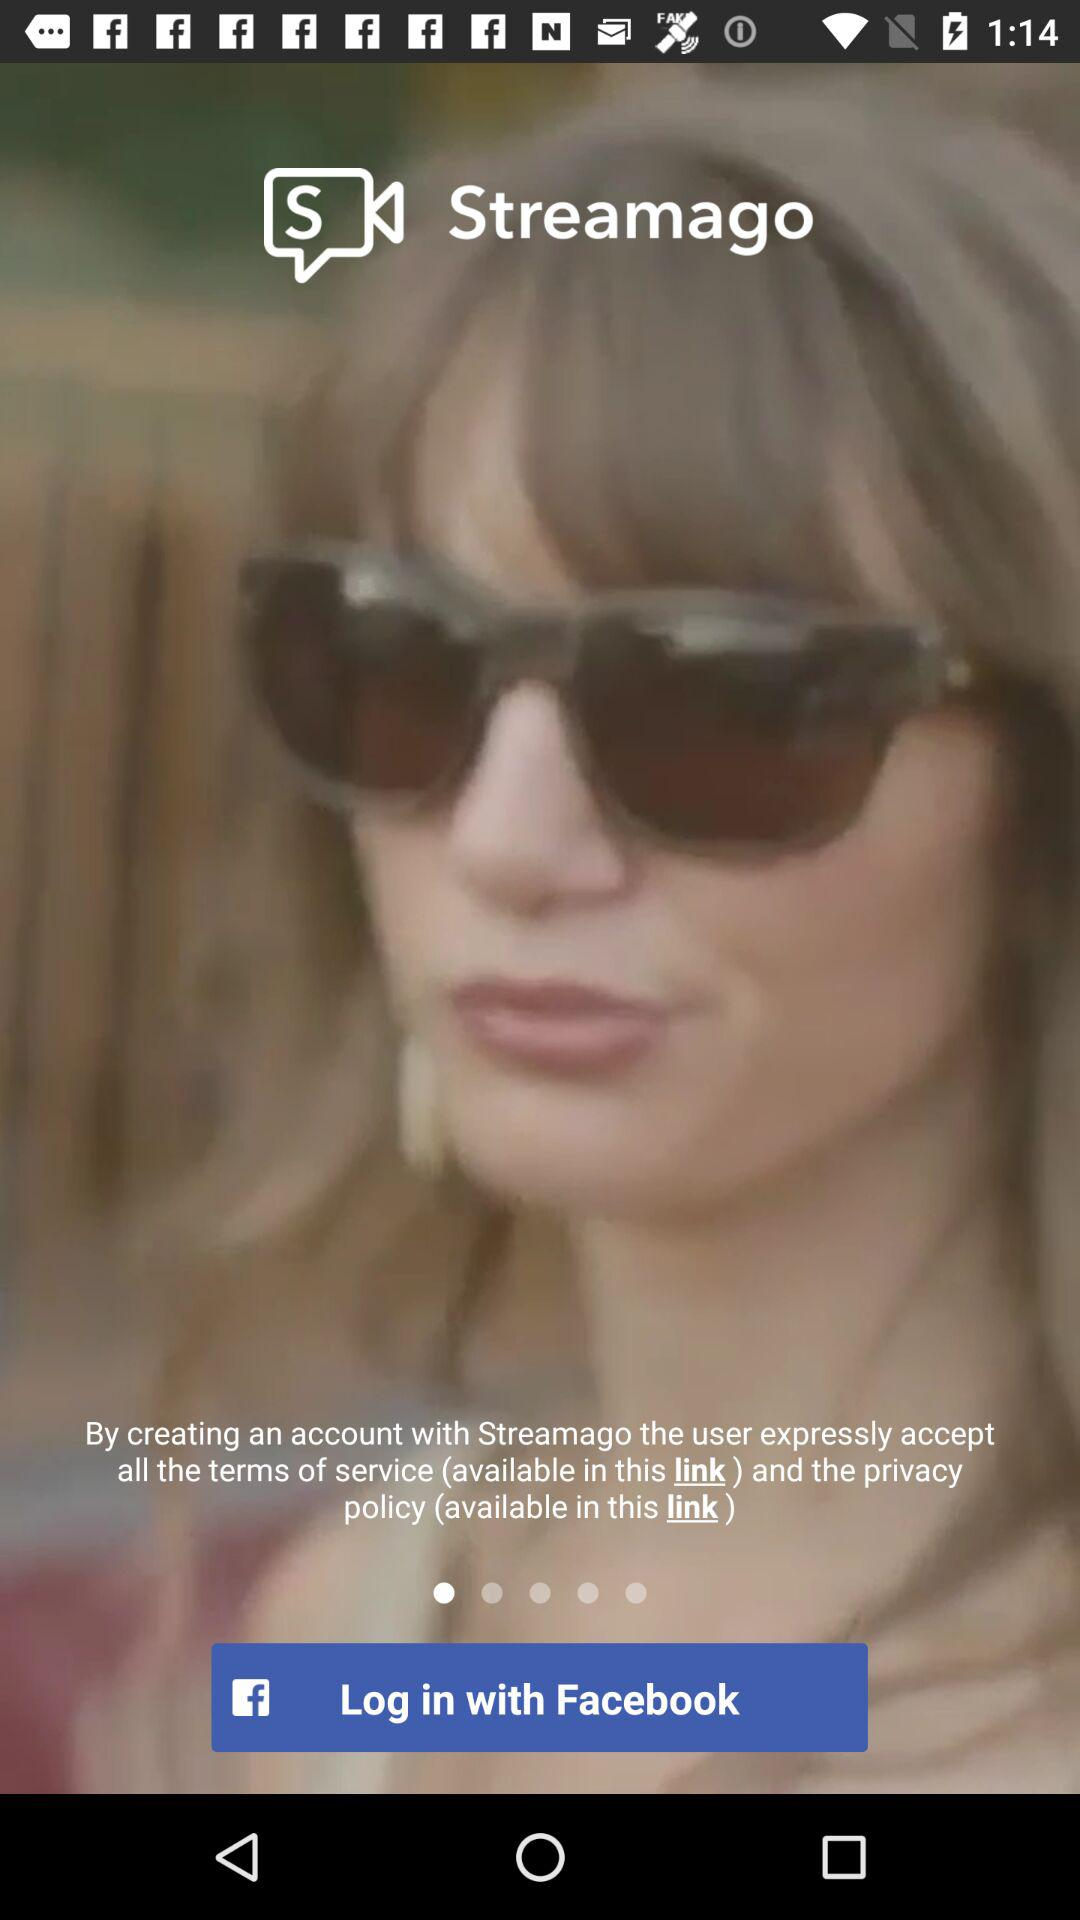What are the different options available to log in? The option available to log in is "Facebook". 